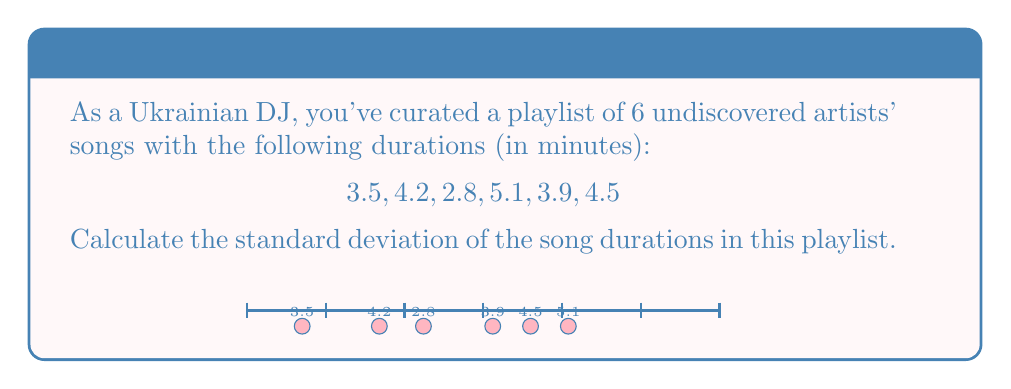Can you answer this question? To calculate the standard deviation, we'll follow these steps:

1. Calculate the mean (average) duration:
   $\bar{x} = \frac{3.5 + 4.2 + 2.8 + 5.1 + 3.9 + 4.5}{6} = 4$ minutes

2. Calculate the squared differences from the mean:
   $(3.5 - 4)^2 = 0.25$
   $(4.2 - 4)^2 = 0.04$
   $(2.8 - 4)^2 = 1.44$
   $(5.1 - 4)^2 = 1.21$
   $(3.9 - 4)^2 = 0.01$
   $(4.5 - 4)^2 = 0.25$

3. Calculate the average of the squared differences:
   $\frac{0.25 + 0.04 + 1.44 + 1.21 + 0.01 + 0.25}{6} = 0.5333$

4. Take the square root of the result:
   $\sqrt{0.5333} = 0.7303$

The formula for standard deviation is:

$$s = \sqrt{\frac{\sum_{i=1}^{n} (x_i - \bar{x})^2}{n}}$$

Where $s$ is the standard deviation, $x_i$ are the individual values, $\bar{x}$ is the mean, and $n$ is the number of values.
Answer: 0.7303 minutes 